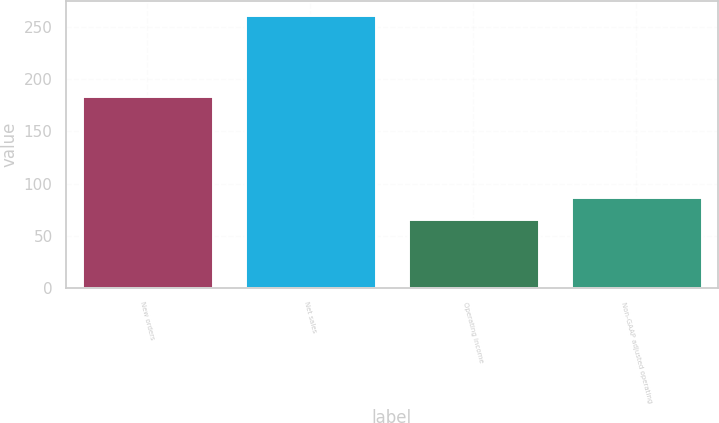Convert chart. <chart><loc_0><loc_0><loc_500><loc_500><bar_chart><fcel>New orders<fcel>Net sales<fcel>Operating income<fcel>Non-GAAP adjusted operating<nl><fcel>184<fcel>262<fcel>66<fcel>87<nl></chart> 